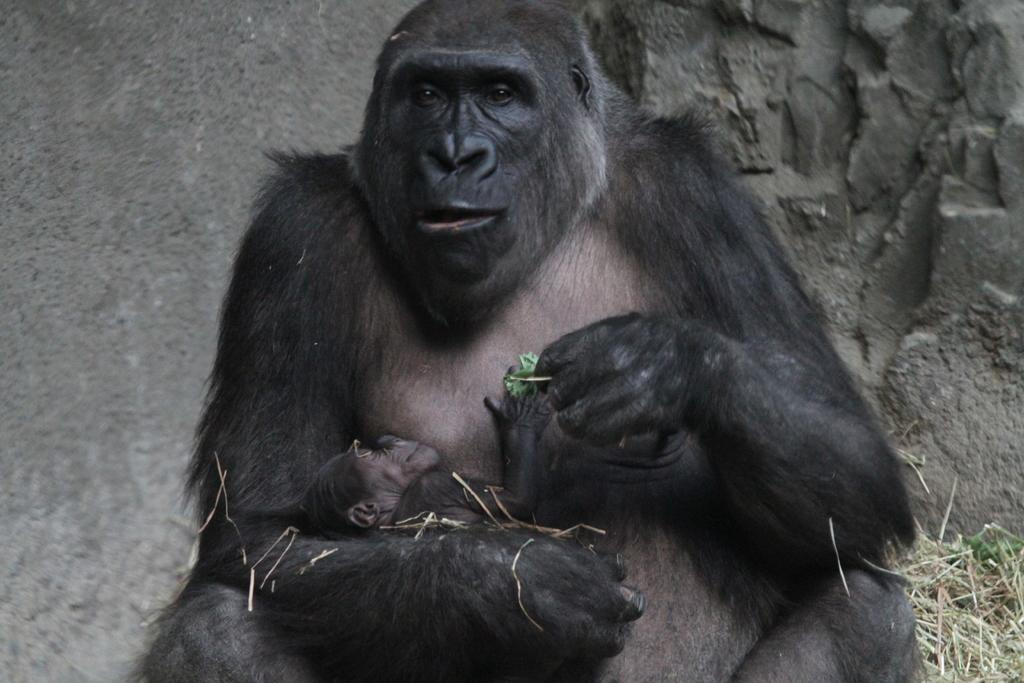What animal is sitting in the image? There is a chimpanzee sitting in the image. What is the chimpanzee doing with its hands? The chimpanzee is holding a baby chimpanzee. What can be seen in the background of the image? There is a wall in the background of the image. What type of ground is visible at the bottom of the image? There is grass visible at the bottom of the image. What grade is the chimpanzee teaching in the image? There is no indication in the image that the chimpanzee is teaching or that there is a grade involved. 